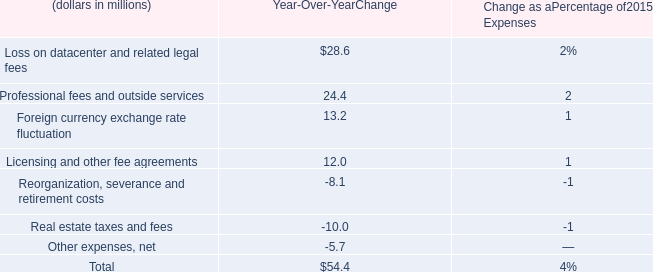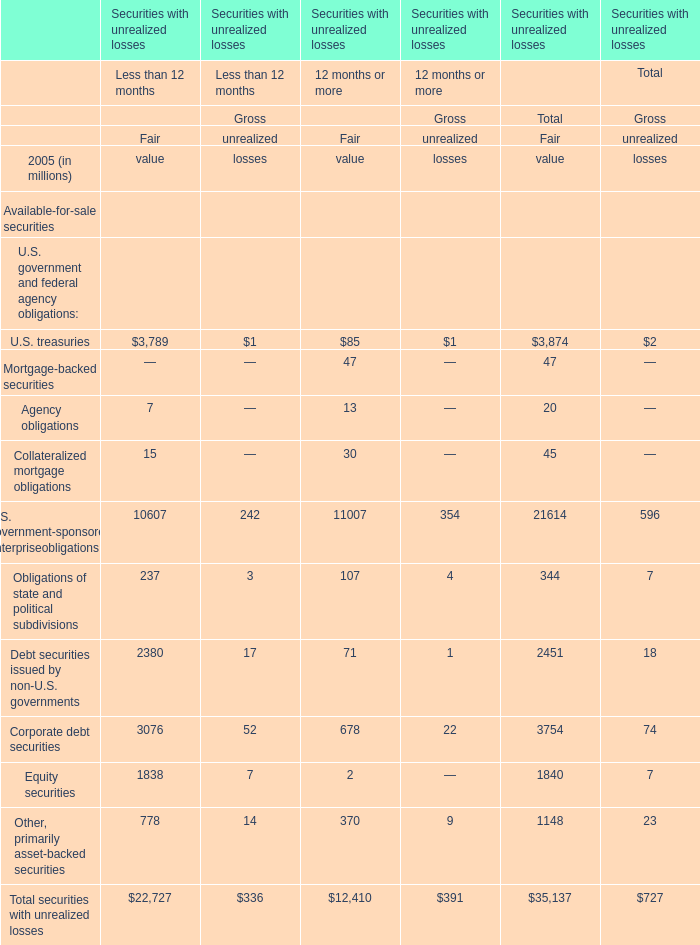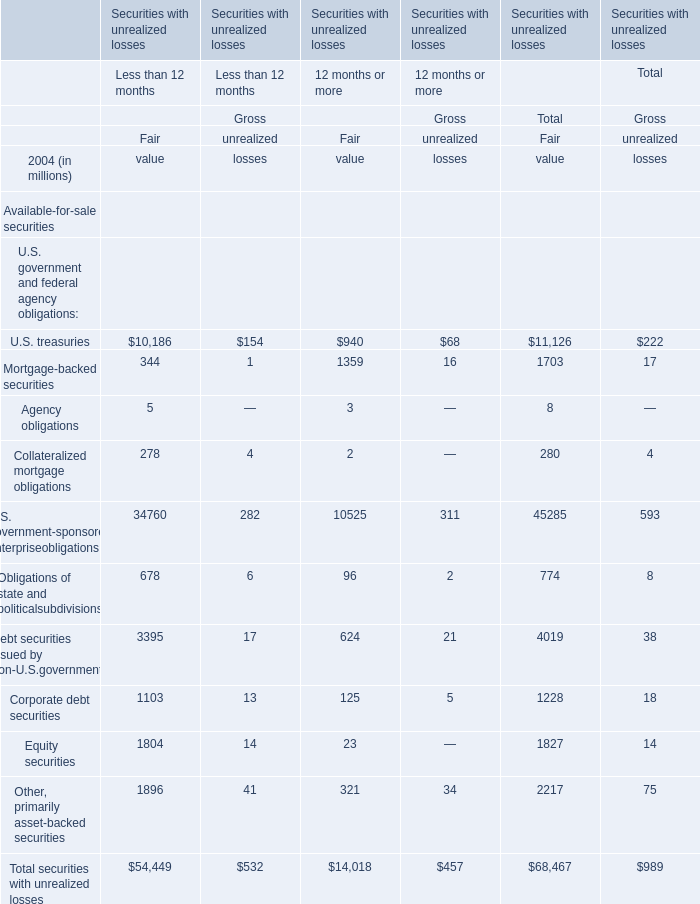What's the sum of all elements that are positive for Fair of 12 months or more? (in million) 
Computations: (((((((((940 + 1359) + 3) + 2) + 10525) + 96) + 624) + 125) + 23) + 321)
Answer: 14018.0. 